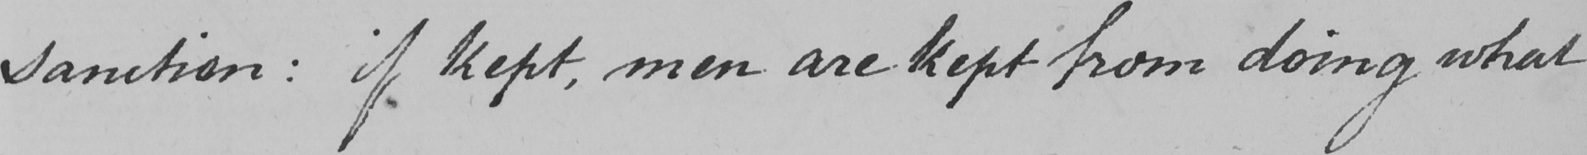Please provide the text content of this handwritten line. sanction :  if kept , men are kept from doing what 